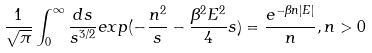Convert formula to latex. <formula><loc_0><loc_0><loc_500><loc_500>\frac { 1 } { \sqrt { \pi } } \int _ { 0 } ^ { \infty } \frac { d s } { s ^ { 3 / 2 } } e x p ( - \frac { n ^ { 2 } } { s } - \frac { \beta ^ { 2 } E ^ { 2 } } { 4 } s ) = \frac { e ^ { - \beta n | E | } } { n } , n > 0</formula> 